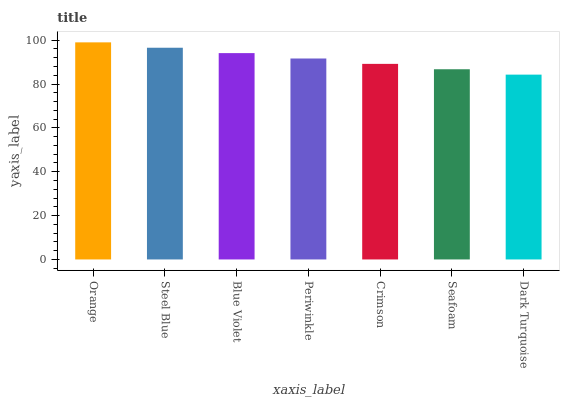Is Steel Blue the minimum?
Answer yes or no. No. Is Steel Blue the maximum?
Answer yes or no. No. Is Orange greater than Steel Blue?
Answer yes or no. Yes. Is Steel Blue less than Orange?
Answer yes or no. Yes. Is Steel Blue greater than Orange?
Answer yes or no. No. Is Orange less than Steel Blue?
Answer yes or no. No. Is Periwinkle the high median?
Answer yes or no. Yes. Is Periwinkle the low median?
Answer yes or no. Yes. Is Dark Turquoise the high median?
Answer yes or no. No. Is Orange the low median?
Answer yes or no. No. 